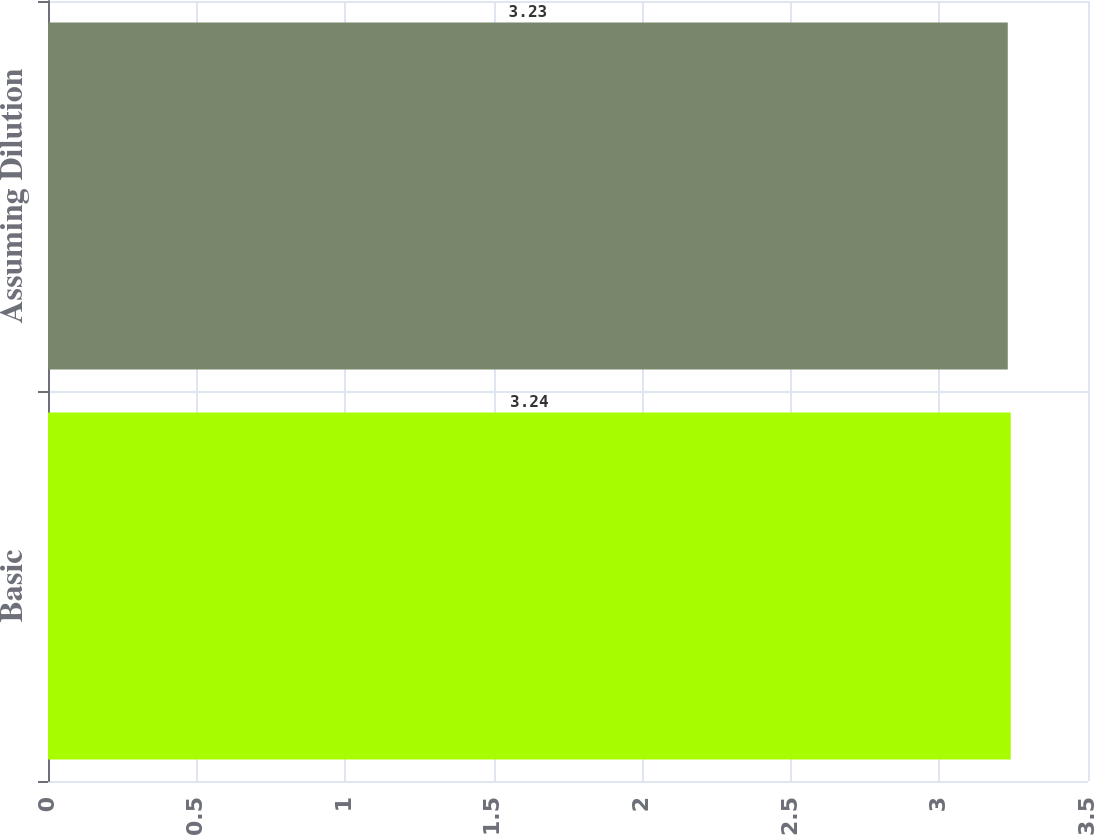Convert chart. <chart><loc_0><loc_0><loc_500><loc_500><bar_chart><fcel>Basic<fcel>Assuming Dilution<nl><fcel>3.24<fcel>3.23<nl></chart> 